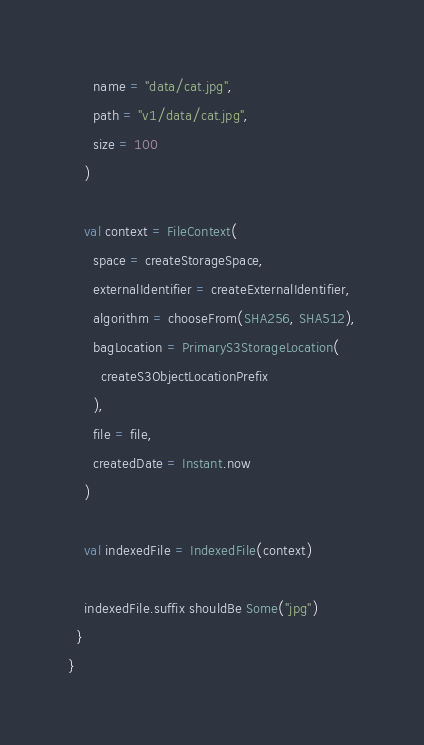Convert code to text. <code><loc_0><loc_0><loc_500><loc_500><_Scala_>      name = "data/cat.jpg",
      path = "v1/data/cat.jpg",
      size = 100
    )

    val context = FileContext(
      space = createStorageSpace,
      externalIdentifier = createExternalIdentifier,
      algorithm = chooseFrom(SHA256, SHA512),
      bagLocation = PrimaryS3StorageLocation(
        createS3ObjectLocationPrefix
      ),
      file = file,
      createdDate = Instant.now
    )

    val indexedFile = IndexedFile(context)

    indexedFile.suffix shouldBe Some("jpg")
  }
}
</code> 